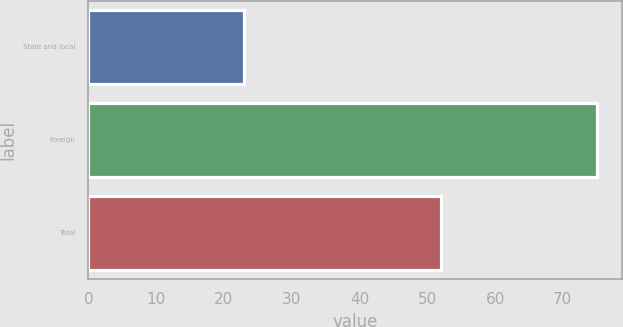Convert chart to OTSL. <chart><loc_0><loc_0><loc_500><loc_500><bar_chart><fcel>State and local<fcel>Foreign<fcel>Total<nl><fcel>23<fcel>75<fcel>52<nl></chart> 